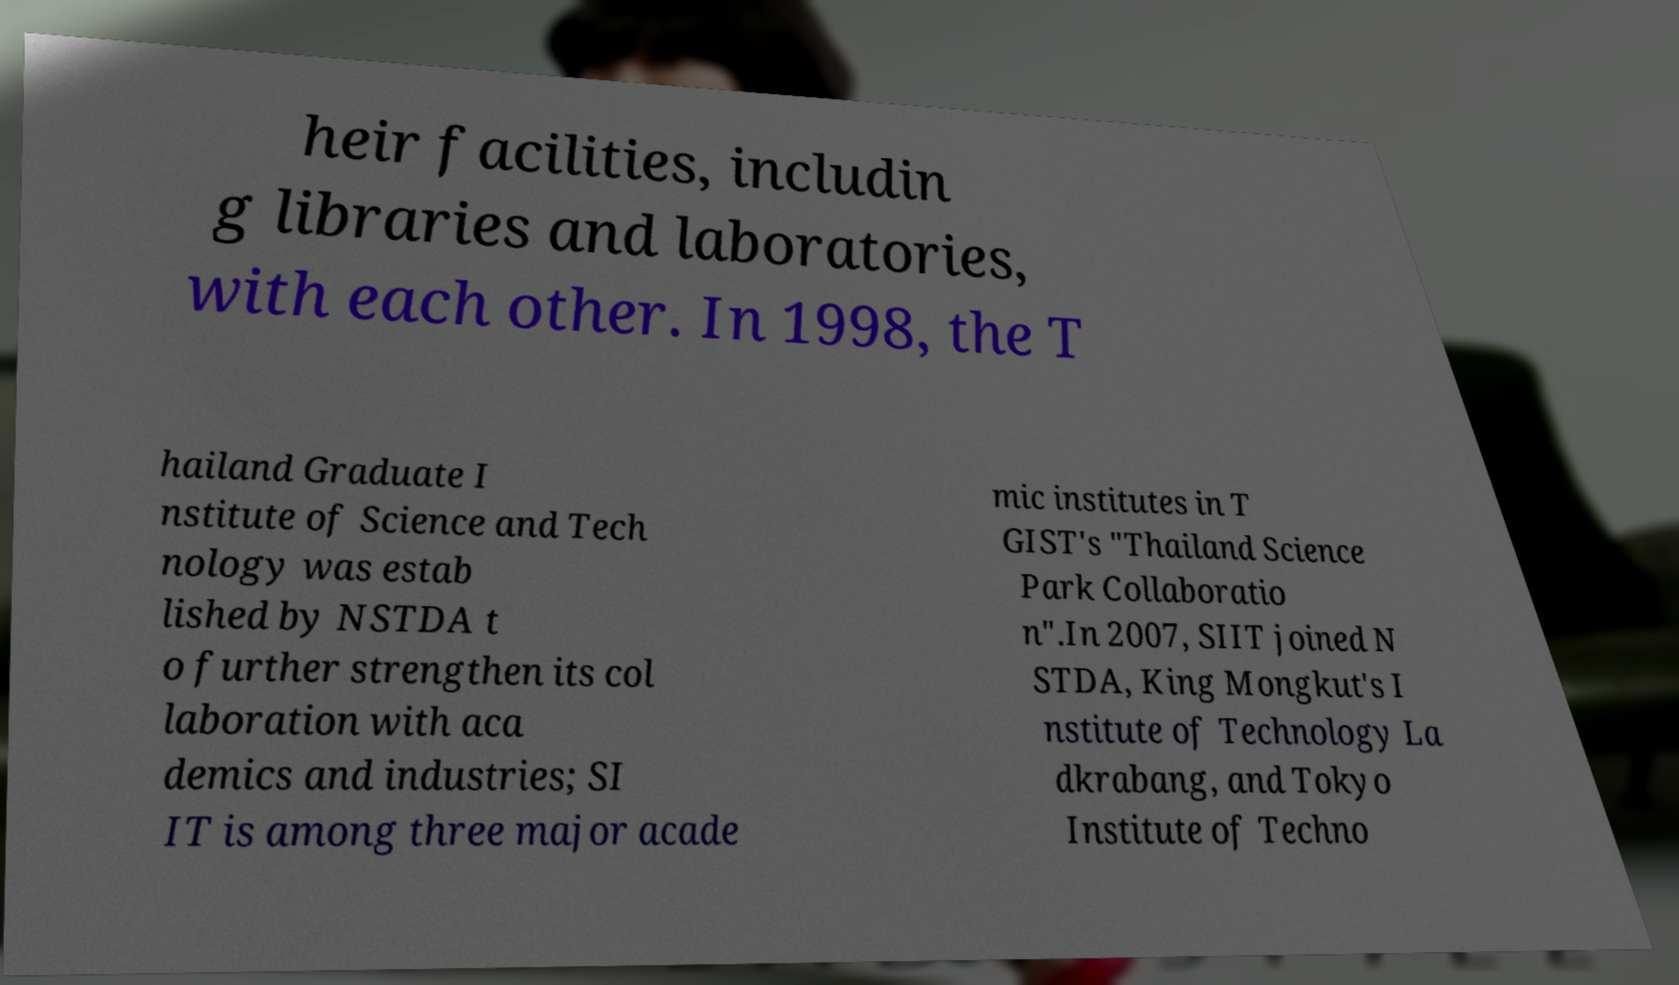For documentation purposes, I need the text within this image transcribed. Could you provide that? heir facilities, includin g libraries and laboratories, with each other. In 1998, the T hailand Graduate I nstitute of Science and Tech nology was estab lished by NSTDA t o further strengthen its col laboration with aca demics and industries; SI IT is among three major acade mic institutes in T GIST's "Thailand Science Park Collaboratio n".In 2007, SIIT joined N STDA, King Mongkut's I nstitute of Technology La dkrabang, and Tokyo Institute of Techno 